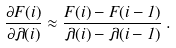<formula> <loc_0><loc_0><loc_500><loc_500>\frac { \partial F ( i ) } { \partial \lambda ( i ) } \approx \frac { F ( i ) - F ( i - 1 ) } { \lambda ( i ) - \lambda ( i - 1 ) } \, .</formula> 